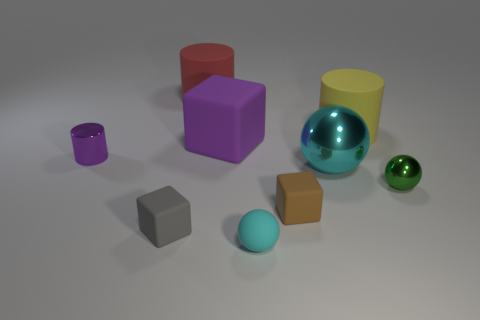What number of other large things are the same shape as the big metal thing?
Ensure brevity in your answer.  0. How many things are either large matte cubes that are left of the tiny brown block or big matte things that are on the right side of the brown rubber object?
Provide a succinct answer. 2. What is the material of the tiny cube right of the rubber cube behind the tiny object left of the tiny gray cube?
Offer a very short reply. Rubber. Do the cylinder in front of the large purple rubber block and the rubber sphere have the same color?
Offer a terse response. No. What material is the block that is both on the left side of the rubber sphere and in front of the small green shiny object?
Make the answer very short. Rubber. Are there any brown cylinders of the same size as the yellow matte cylinder?
Offer a terse response. No. How many large cyan cylinders are there?
Provide a succinct answer. 0. There is a cyan rubber object; how many small gray blocks are to the right of it?
Offer a very short reply. 0. Does the purple cylinder have the same material as the red cylinder?
Your answer should be very brief. No. What number of matte objects are in front of the green object and right of the big rubber cube?
Provide a short and direct response. 2. 